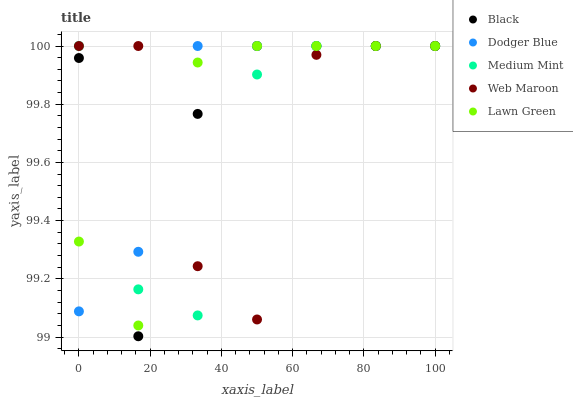Does Medium Mint have the minimum area under the curve?
Answer yes or no. Yes. Does Dodger Blue have the maximum area under the curve?
Answer yes or no. Yes. Does Black have the minimum area under the curve?
Answer yes or no. No. Does Black have the maximum area under the curve?
Answer yes or no. No. Is Dodger Blue the smoothest?
Answer yes or no. Yes. Is Web Maroon the roughest?
Answer yes or no. Yes. Is Black the smoothest?
Answer yes or no. No. Is Black the roughest?
Answer yes or no. No. Does Black have the lowest value?
Answer yes or no. Yes. Does Dodger Blue have the lowest value?
Answer yes or no. No. Does Lawn Green have the highest value?
Answer yes or no. Yes. Does Medium Mint intersect Dodger Blue?
Answer yes or no. Yes. Is Medium Mint less than Dodger Blue?
Answer yes or no. No. Is Medium Mint greater than Dodger Blue?
Answer yes or no. No. 